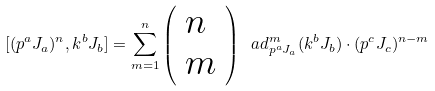<formula> <loc_0><loc_0><loc_500><loc_500>[ ( p ^ { a } J _ { a } ) ^ { n } , k ^ { b } J _ { b } ] = \sum _ { m = 1 } ^ { n } \left ( \begin{array} { l } n \\ m \end{array} \right ) \ a d _ { p ^ { a } J _ { a } } ^ { m } ( k ^ { b } J _ { b } ) \cdot ( p ^ { c } J _ { c } ) ^ { n - m }</formula> 